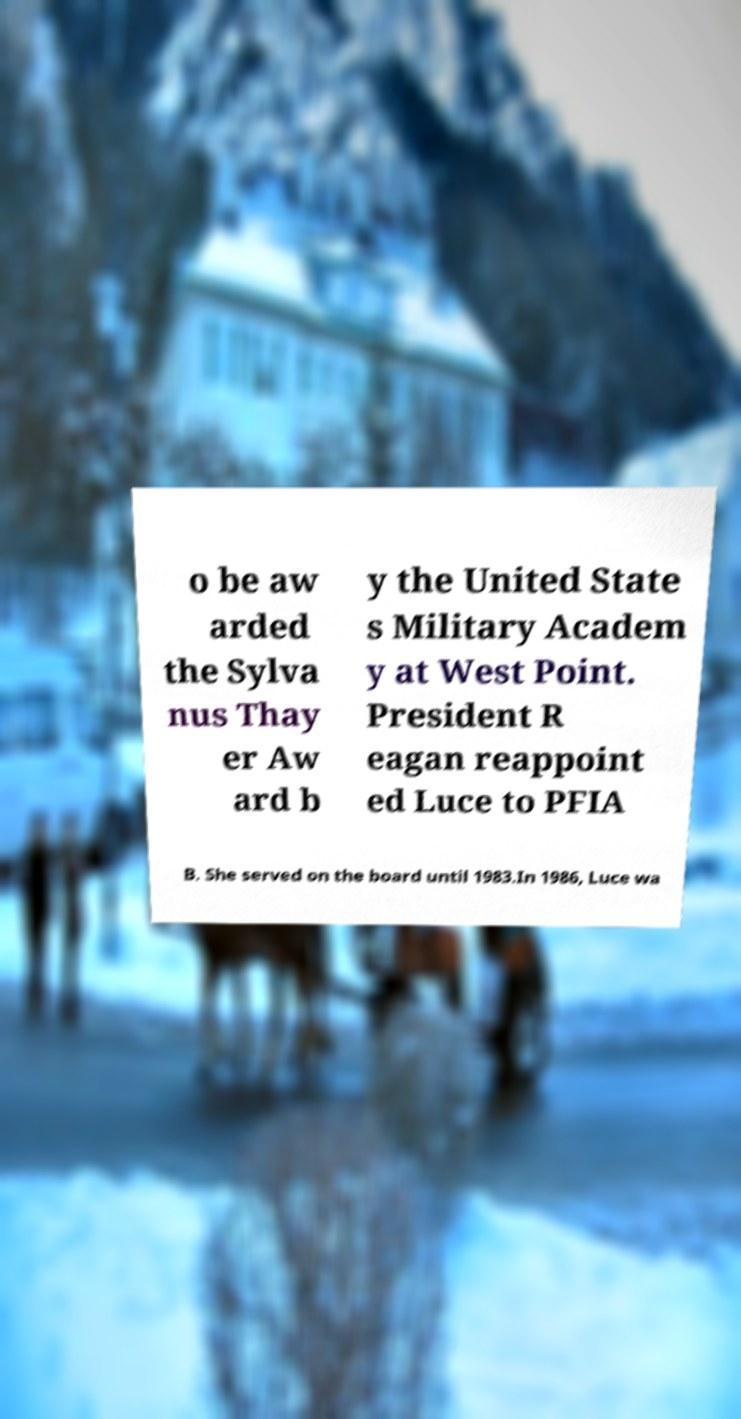What messages or text are displayed in this image? I need them in a readable, typed format. o be aw arded the Sylva nus Thay er Aw ard b y the United State s Military Academ y at West Point. President R eagan reappoint ed Luce to PFIA B. She served on the board until 1983.In 1986, Luce wa 